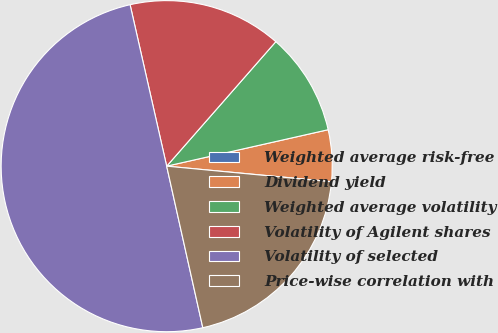Convert chart to OTSL. <chart><loc_0><loc_0><loc_500><loc_500><pie_chart><fcel>Weighted average risk-free<fcel>Dividend yield<fcel>Weighted average volatility<fcel>Volatility of Agilent shares<fcel>Volatility of selected<fcel>Price-wise correlation with<nl><fcel>0.02%<fcel>5.02%<fcel>10.01%<fcel>15.0%<fcel>49.95%<fcel>19.99%<nl></chart> 